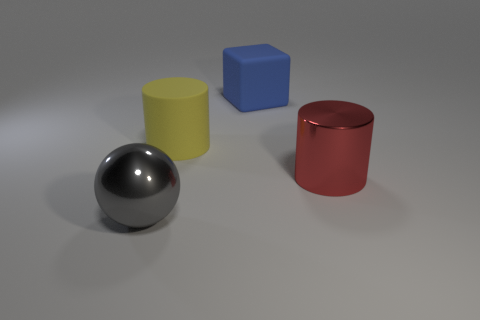Add 3 tiny purple matte spheres. How many objects exist? 7 Subtract all spheres. How many objects are left? 3 Add 3 big gray things. How many big gray things exist? 4 Subtract 1 gray balls. How many objects are left? 3 Subtract all tiny brown things. Subtract all blue rubber blocks. How many objects are left? 3 Add 4 metal objects. How many metal objects are left? 6 